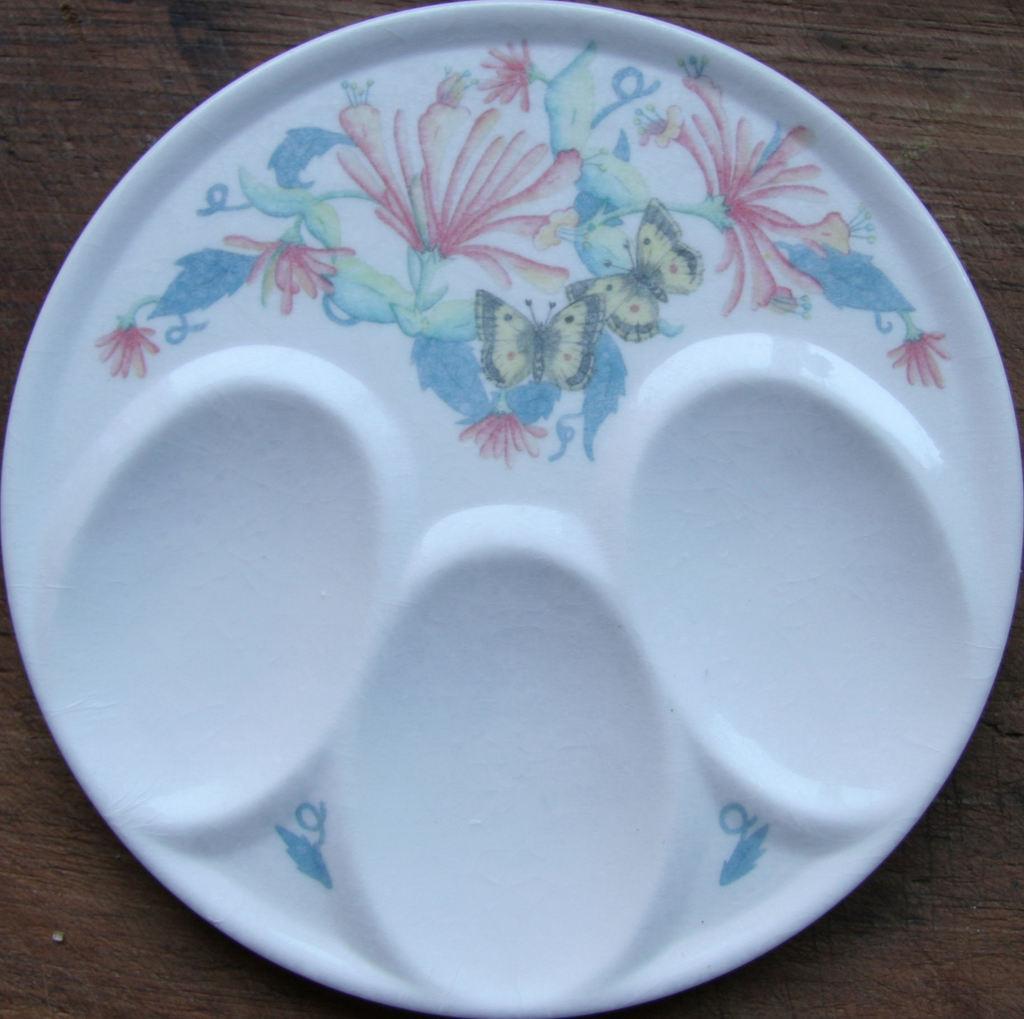Could you give a brief overview of what you see in this image? In this picture we can see a plate on a wooden surface. There is some art visible on this plate. 